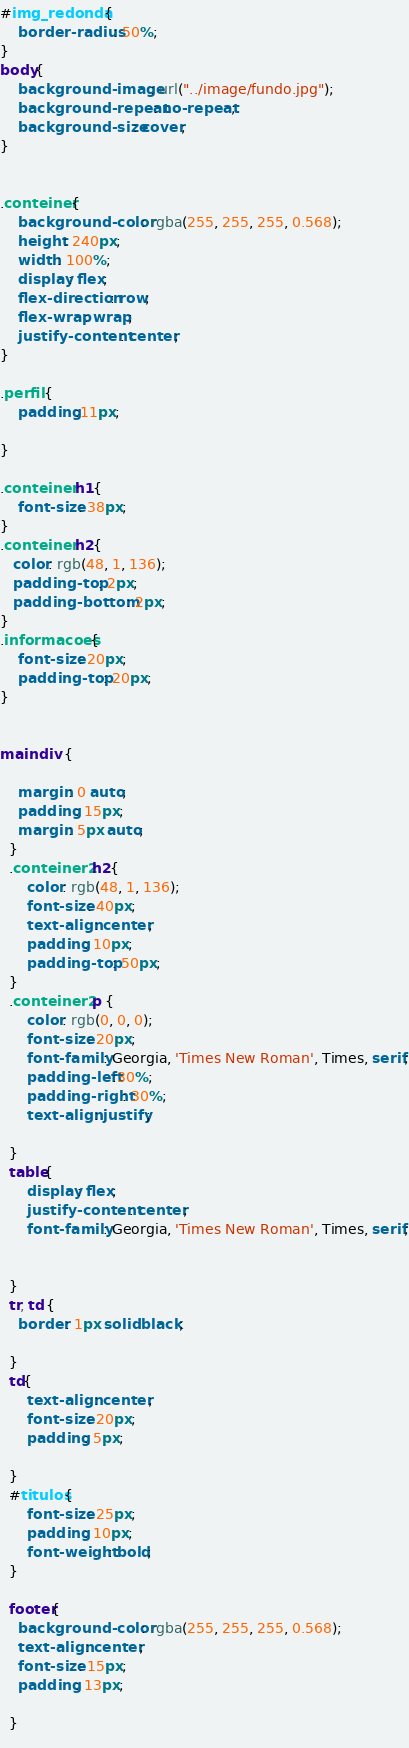Convert code to text. <code><loc_0><loc_0><loc_500><loc_500><_CSS_>#img_redonda{
    border-radius: 50%;
}
body{
    background-image: url("../image/fundo.jpg");
    background-repeat: no-repeat;
    background-size: cover;
}


.conteiner{
    background-color: rgba(255, 255, 255, 0.568);
    height: 240px;
    width: 100%;
    display: flex;
    flex-direction: row;
    flex-wrap: wrap;
    justify-content: center;
}

.perfil {
    padding:11px;

}

.conteiner h1{
    font-size: 38px;
}
.conteiner h2{
   color: rgb(48, 1, 136);
   padding-top: 2px;
   padding-bottom: 2px;
}
.informacoes{
    font-size: 20px;
    padding-top: 20px;
}


main div {
    
    margin: 0 auto;
    padding: 15px;
    margin: 5px auto;
  }
  .conteiner2 h2{
      color: rgb(48, 1, 136);
      font-size: 40px;
      text-align: center;
      padding: 10px;
      padding-top: 50px;
  }
  .conteiner2 p {
      color: rgb(0, 0, 0);
      font-size: 20px;
      font-family: Georgia, 'Times New Roman', Times, serif;
      padding-left:30%;
      padding-right: 30%;
      text-align: justify;
      
  }
  table{
      display: flex;
      justify-content: center;
      font-family: Georgia, 'Times New Roman', Times, serif;
      
      
  }
  tr, td {
    border: 1px solid black;

  }
  td{
      text-align: center;
      font-size: 20px;
      padding: 5px;

  }
  #titulos{
      font-size: 25px;
      padding: 10px;
      font-weight: bold;
  }
      
  footer{
    background-color: rgba(255, 255, 255, 0.568);
    text-align: center;
    font-size: 15px;
    padding: 13px;

  }
  
</code> 